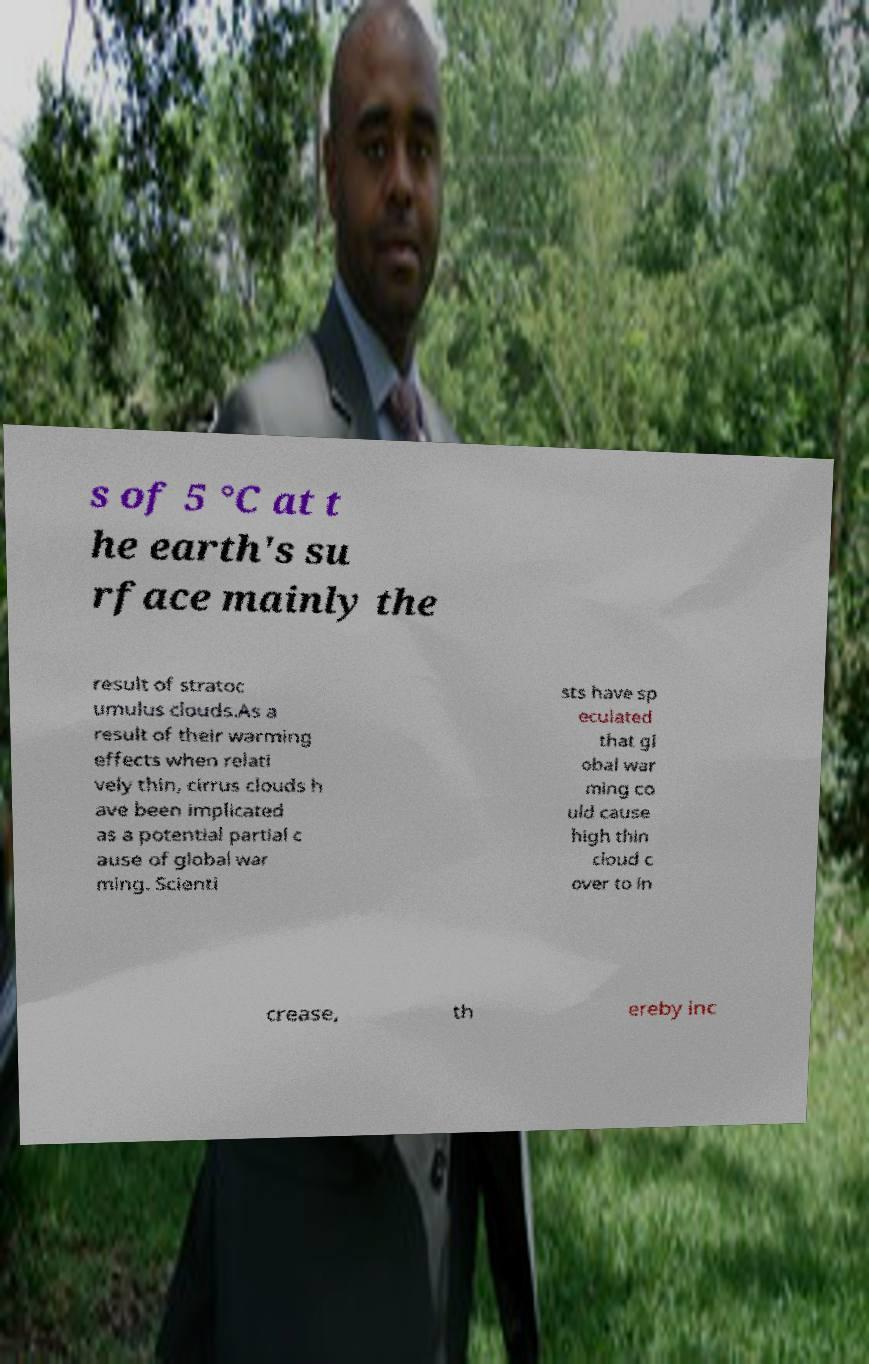For documentation purposes, I need the text within this image transcribed. Could you provide that? s of 5 °C at t he earth's su rface mainly the result of stratoc umulus clouds.As a result of their warming effects when relati vely thin, cirrus clouds h ave been implicated as a potential partial c ause of global war ming. Scienti sts have sp eculated that gl obal war ming co uld cause high thin cloud c over to in crease, th ereby inc 